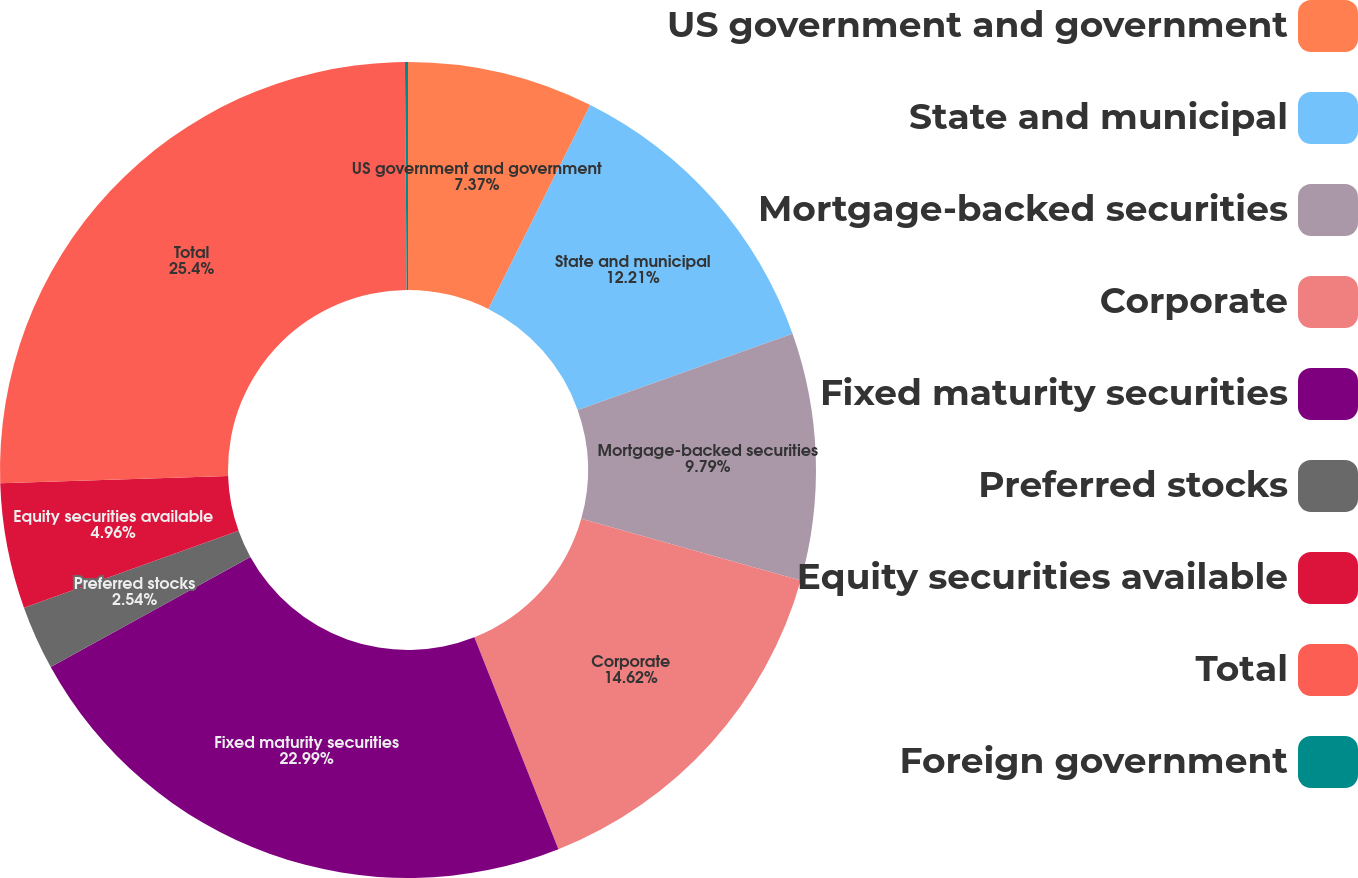Convert chart to OTSL. <chart><loc_0><loc_0><loc_500><loc_500><pie_chart><fcel>US government and government<fcel>State and municipal<fcel>Mortgage-backed securities<fcel>Corporate<fcel>Fixed maturity securities<fcel>Preferred stocks<fcel>Equity securities available<fcel>Total<fcel>Foreign government<nl><fcel>7.37%<fcel>12.21%<fcel>9.79%<fcel>14.62%<fcel>22.99%<fcel>2.54%<fcel>4.96%<fcel>25.4%<fcel>0.12%<nl></chart> 